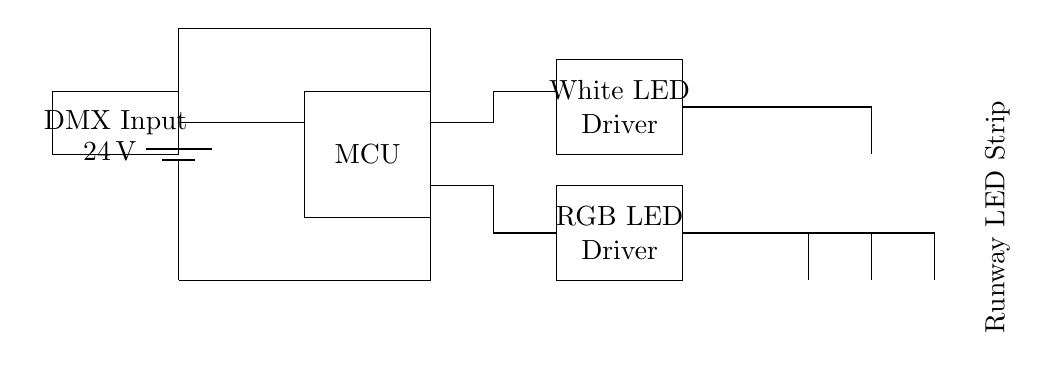What is the input voltage of the circuit? The input voltage is indicated by the battery symbol, which shows a potential difference of 24 volts.
Answer: 24 volts What type of microcontroller is used? The circuit diagram labels the component as "MCU," which stands for microcontroller but does not specify a model. It is a generic representation of a microcontroller used for control.
Answer: MCU How many LED drivers are present in the circuit? The diagram shows two distinct rectangles labeled for different types of LED drivers: one for RGB LED Driver and another for White LED Driver, indicating a total of two LED drivers in the circuit.
Answer: Two What is the purpose of the DMX input in this circuit? The DMX input serves as a control signal interface, likely intended for controlling the lighting effects of the LEDs, allowing for communication with lighting control systems.
Answer: Control interface What type of LEDs are connected to the RGB LED driver? The circuit shows three colored LEDs labeled as red, green, and blue connected to the RGB LED driver, which indicates that these LEDs are specifically for color mixing and effects.
Answer: Red, green, blue How does the white LED driver connect to the LED? The connection line from the white LED driver goes directly to one single LED, suggesting this part of the circuit is dedicated to controlling the white LED independently.
Answer: Direct connection What does the label on the output strip indicate? The label to the right of the LEDs identifies it as a "Runway LED Strip," which signifies that these lights are designed to illuminate the fashion show runway.
Answer: Runway LED Strip 